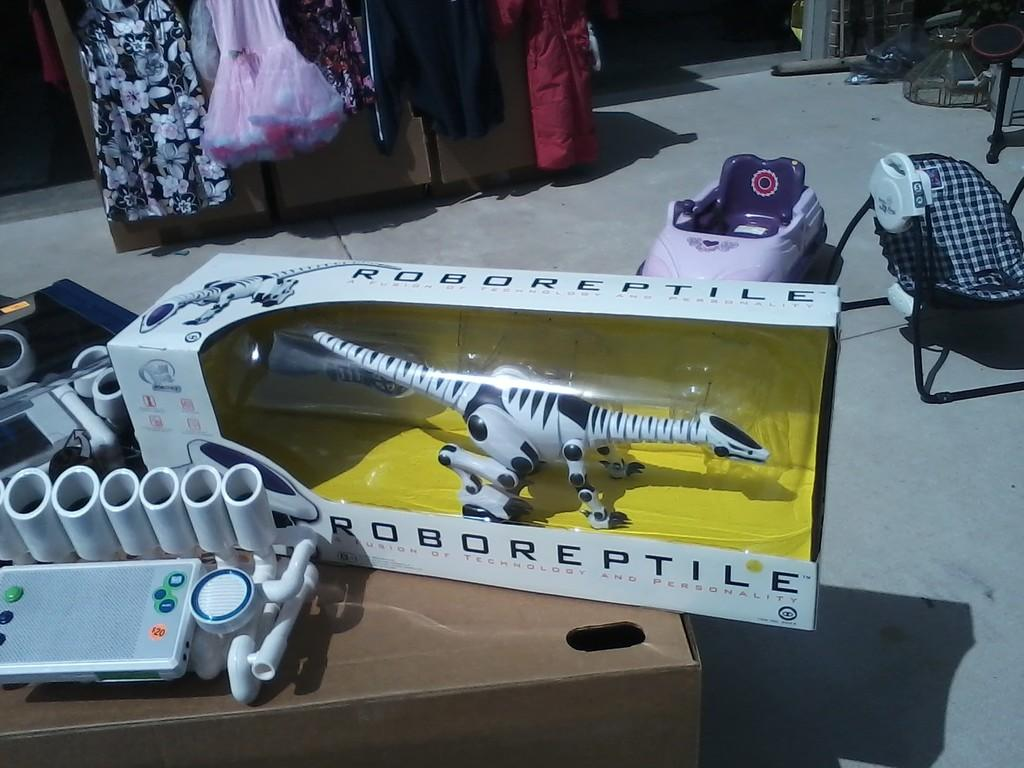<image>
Render a clear and concise summary of the photo. a cluttered room with a RoboReptile in a box 